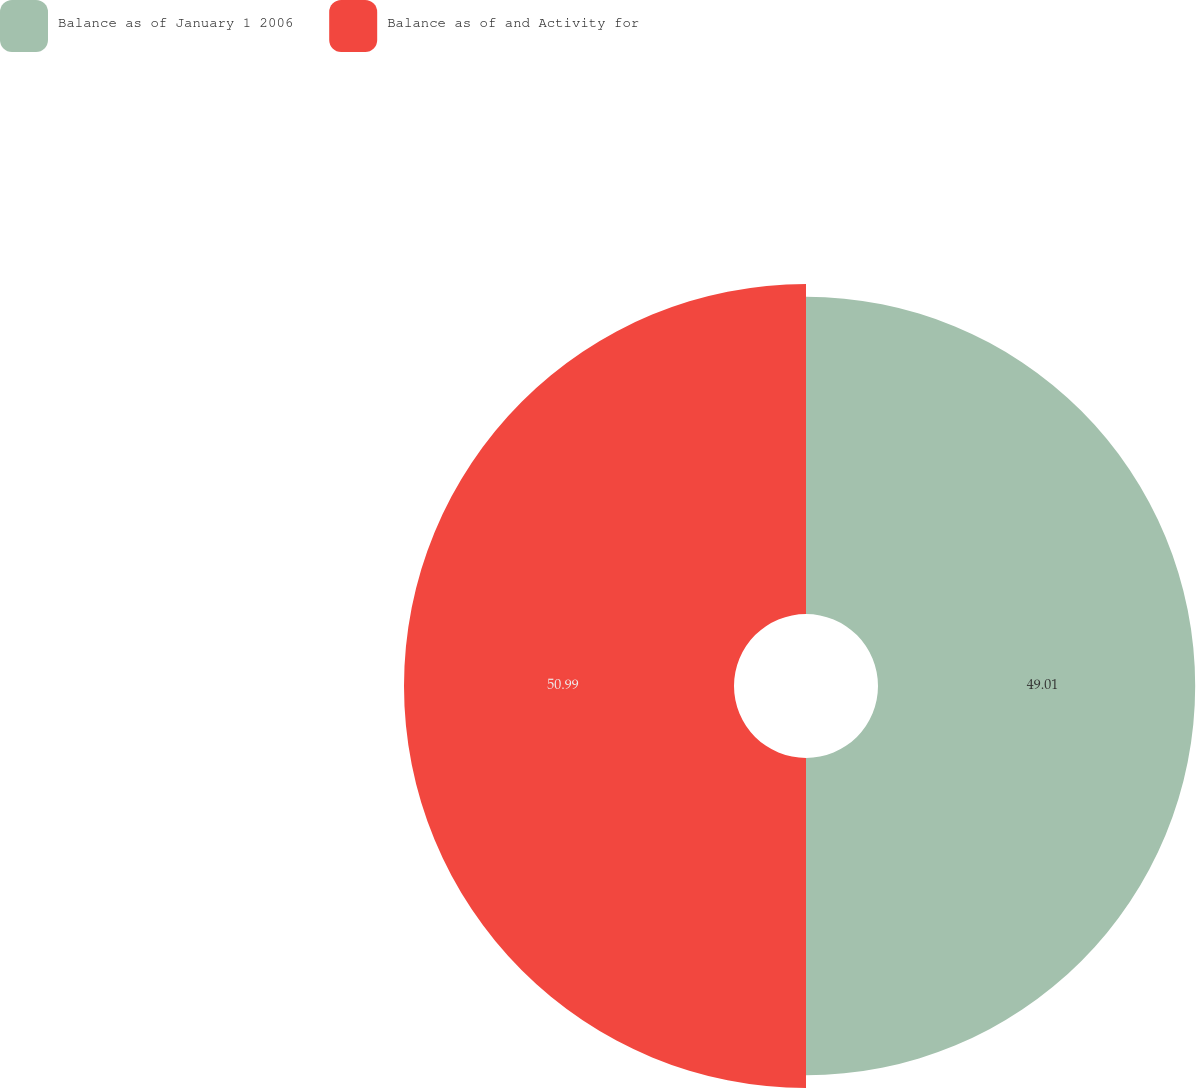Convert chart to OTSL. <chart><loc_0><loc_0><loc_500><loc_500><pie_chart><fcel>Balance as of January 1 2006<fcel>Balance as of and Activity for<nl><fcel>49.01%<fcel>50.99%<nl></chart> 